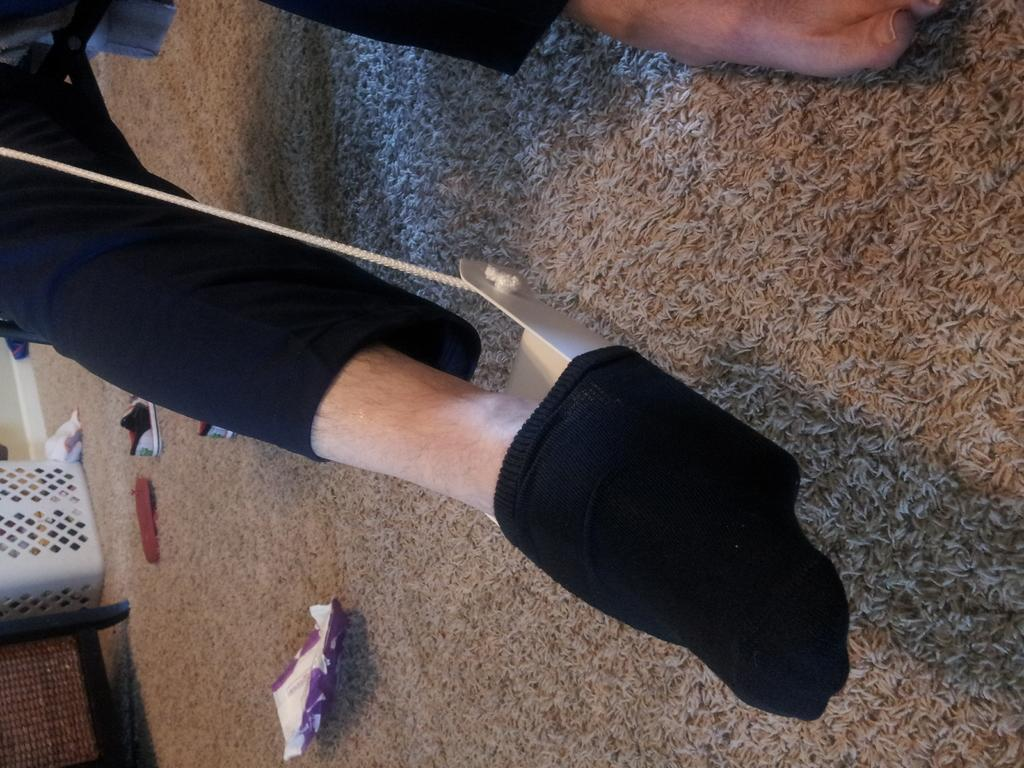What is located in the center of the image? There are two legs in the center of the image. What can be seen in the background of the image? There is a table, a basket, a shoe, a carpet, and papers in the background of the image. What type of skate is being used on the carpet in the image? There is no skate present in the image; it only shows two legs, a table, a basket, a shoe, a carpet, and papers in the background. 